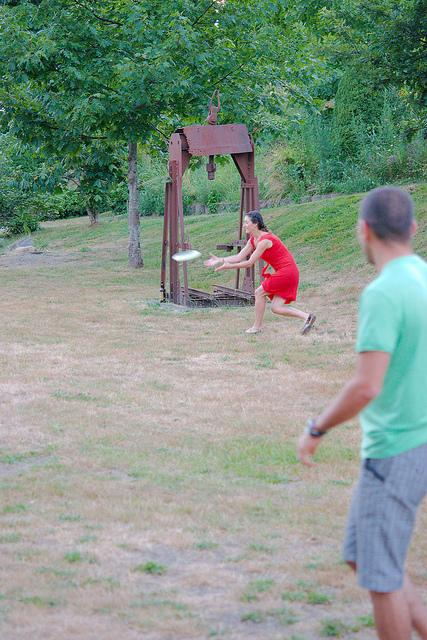What is the woman in red reaching towards? frisbee 